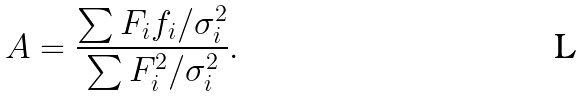<formula> <loc_0><loc_0><loc_500><loc_500>A = \frac { \sum F _ { i } f _ { i } / \sigma _ { i } ^ { 2 } } { \sum F _ { i } ^ { 2 } / \sigma _ { i } ^ { 2 } } .</formula> 